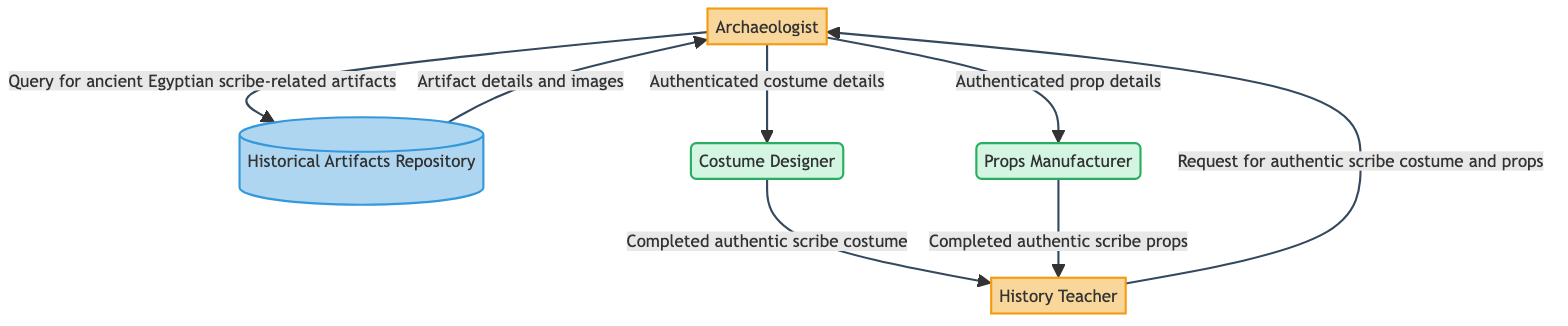What type of entity is the Archaeologist? The Archaeologist is classified as an External Entity, indicating that it is a separate party involved in the process of authenticating historical elements.
Answer: External Entity How many data stores are present in the diagram? There is one data store present, which is the Historical Artifacts Repository. This is verified by counting the nodes in the diagram that are categorized as data stores.
Answer: 1 What is the first action taken by the Archaeologist? The first action taken by the Archaeologist is to query the Historical Artifacts Repository for ancient Egyptian scribe-related artifacts, as shown in the flow from Archaeologist to Historical Artifacts Repository.
Answer: Query for ancient Egyptian scribe-related artifacts Who receives the completed authentic scribe props? The completed authentic scribe props are sent to the History Teacher, as indicated by the flow from Props Manufacturer to History Teacher.
Answer: History Teacher What entity is responsible for creating costumes? The Costume Designer is responsible for creating the costumes, which is evident from the direct flow of authenticated costume details from the Archaeologist to the Costume Designer.
Answer: Costume Designer How many external entities are in the diagram? There are two external entities in the diagram, which are the Archaeologist and the History Teacher. This is determined by counting the nodes marked as external entities.
Answer: 2 What type of entity is the Historical Artifacts Repository? The Historical Artifacts Repository is classified as a Data Store, indicating that it serves as a storage location for information about historical artifacts.
Answer: Data Store What is the final step for the History Teacher? The final step for the History Teacher is to receive the completed authentic scribe costume, as the flow from Costume Designer to History Teacher indicates.
Answer: Completed authentic scribe costume What does the Props Manufacturer produce? The Props Manufacturer produces authenticated props, which can be traced from the Archaeologist to the Props Manufacturer in the flow of authenticated prop details.
Answer: Authenticated props 